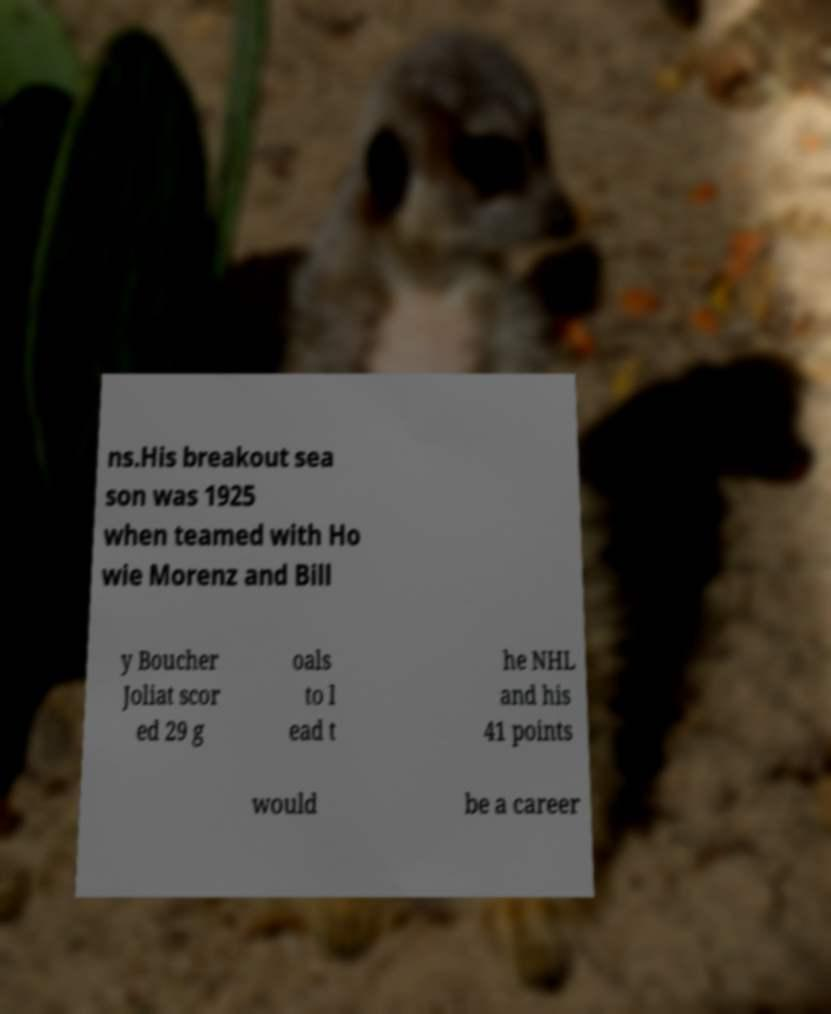Please read and relay the text visible in this image. What does it say? ns.His breakout sea son was 1925 when teamed with Ho wie Morenz and Bill y Boucher Joliat scor ed 29 g oals to l ead t he NHL and his 41 points would be a career 